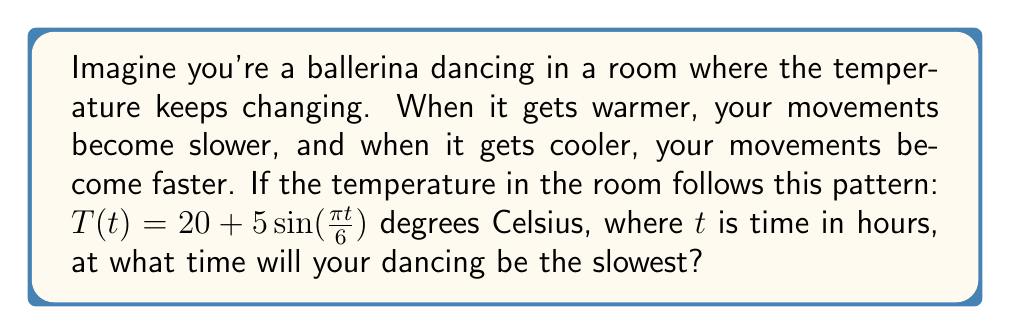Teach me how to tackle this problem. Let's break this down step-by-step:

1. The temperature function is given by $T(t) = 20 + 5\sin(\frac{\pi t}{6})$

2. We know that the ballerina's movements are slowest when the temperature is highest.

3. To find the maximum temperature, we need to find when $\sin(\frac{\pi t}{6})$ is at its maximum.

4. The sine function reaches its maximum value of 1 when its argument is $\frac{\pi}{2}$ (or 90 degrees).

5. So, we need to solve:
   $$\frac{\pi t}{6} = \frac{\pi}{2}$$

6. Multiplying both sides by $\frac{6}{\pi}$:
   $$t = 3$$

7. This means the temperature is highest, and thus the dancing is slowest, 3 hours after the starting point.
Answer: 3 hours 